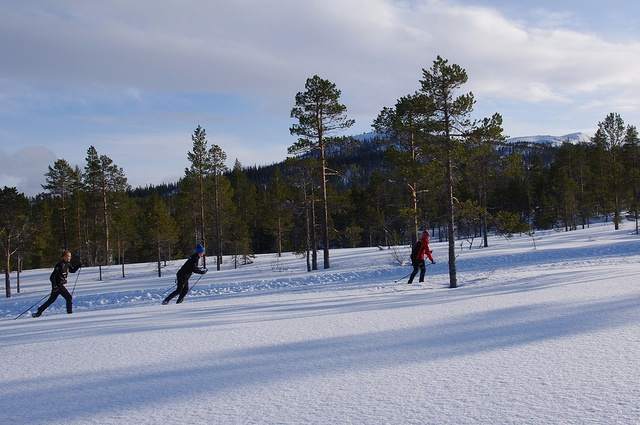Describe the objects in this image and their specific colors. I can see people in gray, black, maroon, and navy tones, people in gray, black, navy, and darkgray tones, people in gray, black, maroon, and darkgray tones, skis in gray, darkgray, and lightgray tones, and skis in gray, navy, and darkgray tones in this image. 